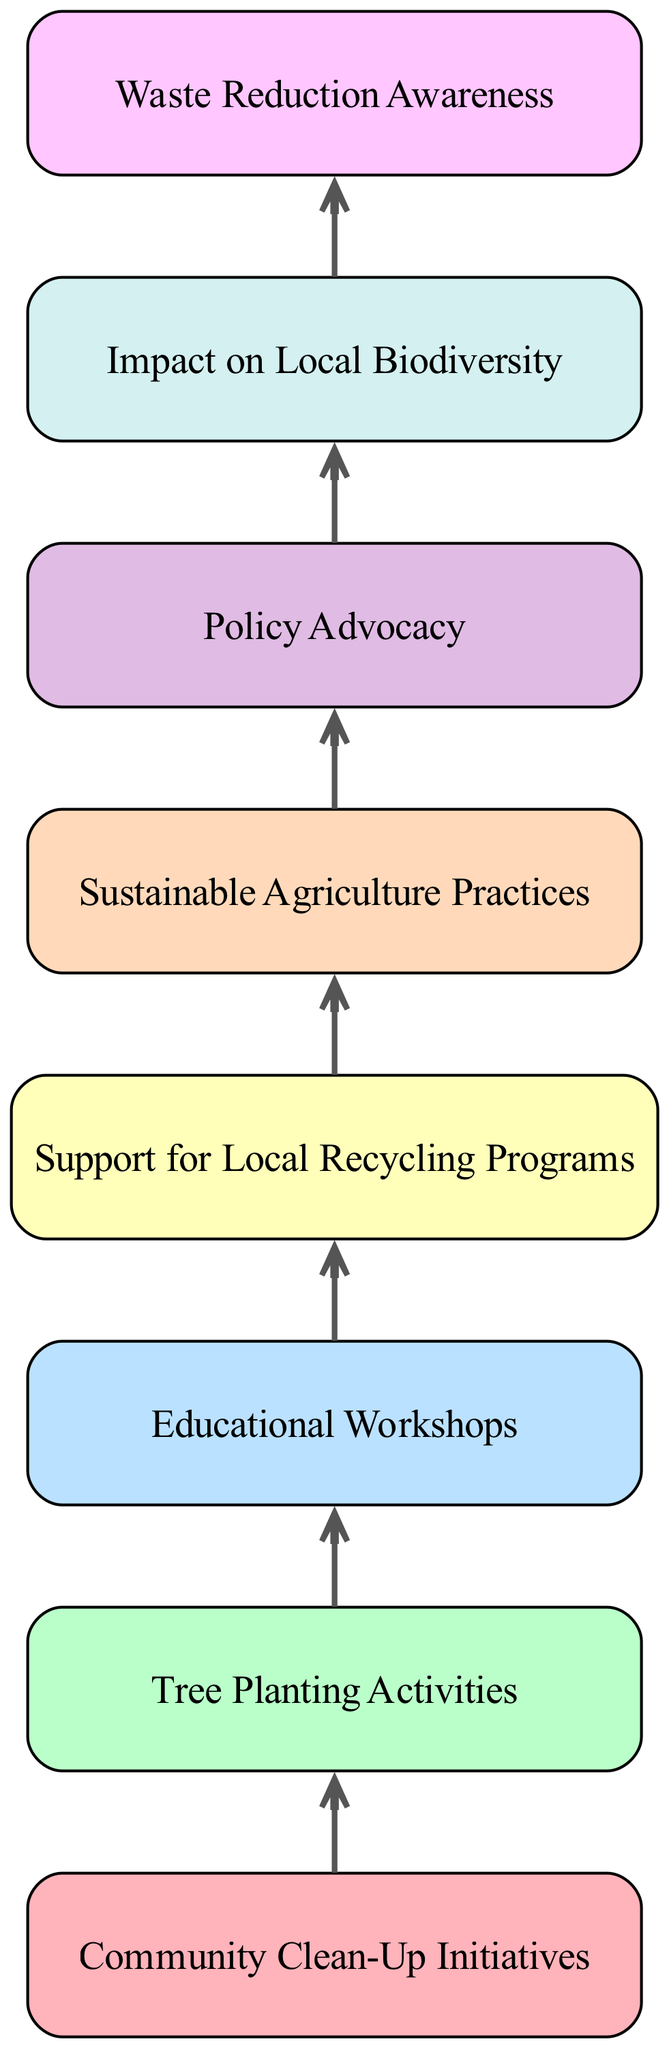What is the first action taken by citizens in the diagram? The first action in the flow chart is "Community Clean-Up Initiatives," which is the initial node. It represents the beginning of citizen actions aimed at promoting environmental sustainability.
Answer: Community Clean-Up Initiatives How many actions are there in total? By counting the nodes listed in the diagram, there are eight distinct actions that citizens take, as indicated in the data provided.
Answer: Eight What action comes after "Educational Workshops"? Following "Educational Workshops," the next action represented in the flow chart is "Support for Local Recycling Programs," which shows the sequential nature of the initiatives taken.
Answer: Support for Local Recycling Programs Which action is related to advocating for policy changes? The action "Policy Advocacy" directly pertains to the efforts by citizens to promote environmentally friendly policies at various governmental levels.
Answer: Policy Advocacy What impact results from the collective actions of citizens? The diagram indicates that the cumulative efforts of citizens lead to an "Impact on Local Biodiversity," which signifies a positive change in the environment.
Answer: Impact on Local Biodiversity Which two actions focus on education? The actions "Educational Workshops" and "Waste Reduction Awareness" both emphasize educating the public on sustainability practices and waste management.
Answer: Educational Workshops, Waste Reduction Awareness What is the last action taken in the flow chart? The final action in the diagram is "Impact on Local Biodiversity," which represents the concluding outcome of the various citizen-led initiatives captured in the flow.
Answer: Impact on Local Biodiversity What color is used for "Tree Planting Activities"? According to the color scheme applied in the flow chart, "Tree Planting Activities" is shaded with the color associated with its position, which corresponds to the specific color noted for that element.
Answer: Color assigned in scheme (Inferred if present) What role do citizens play in "Sustainable Agriculture Practices"? Citizens, particularly farmers, engage in the practice of sustainable agriculture by adopting organic methods and sharing knowledge with others, showcasing their proactive role in environmental stewardship.
Answer: Citizens adopt sustainable practices 